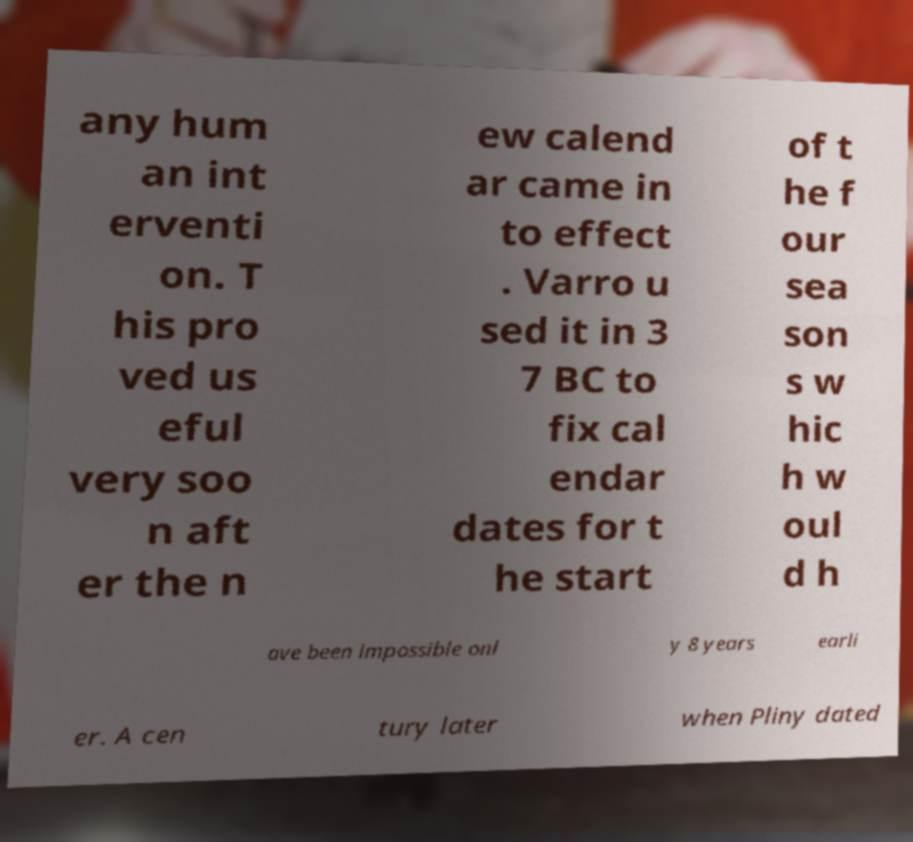Can you accurately transcribe the text from the provided image for me? any hum an int erventi on. T his pro ved us eful very soo n aft er the n ew calend ar came in to effect . Varro u sed it in 3 7 BC to fix cal endar dates for t he start of t he f our sea son s w hic h w oul d h ave been impossible onl y 8 years earli er. A cen tury later when Pliny dated 